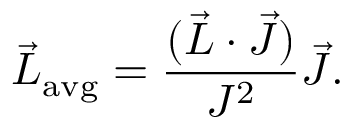<formula> <loc_0><loc_0><loc_500><loc_500>{ \vec { L } } _ { a v g } = { \frac { ( { \vec { L } } \cdot { \vec { J } } ) } { J ^ { 2 } } } { \vec { J } } .</formula> 